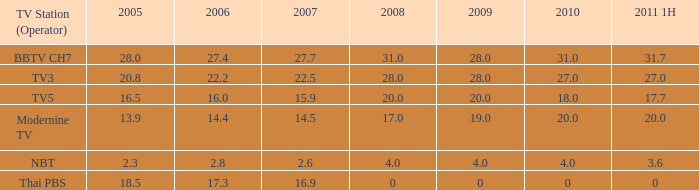3, 2010 over 4, and 2011 1h equal to 20? 1.0. 